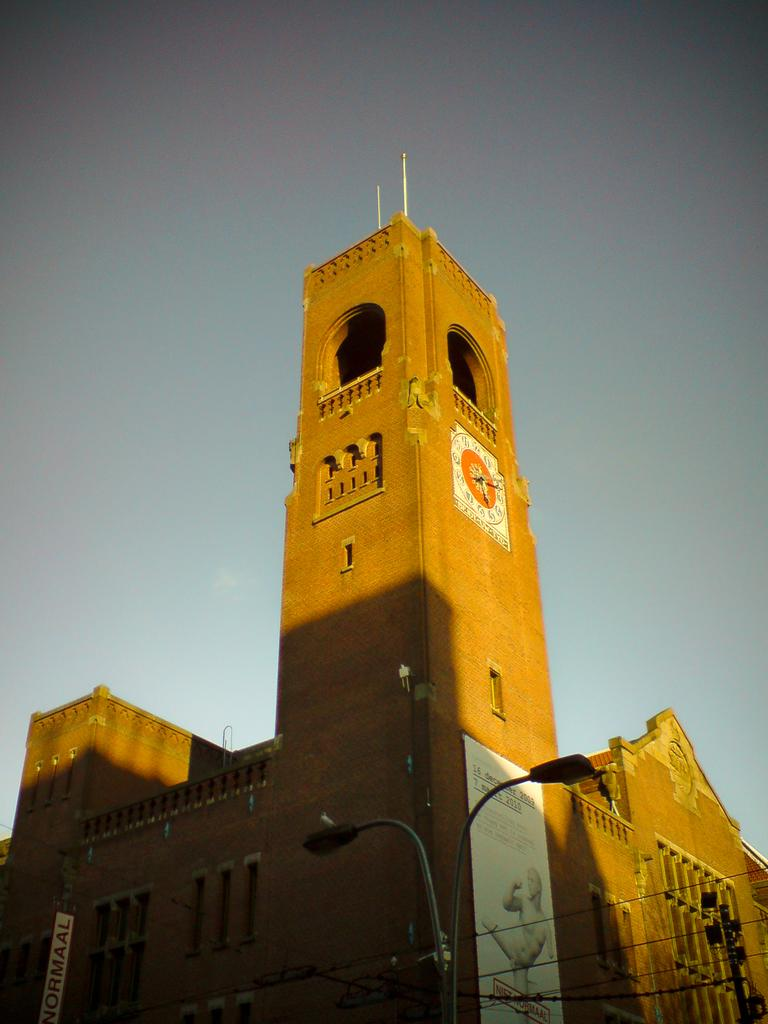What type of structure is visible in the image? There is a building in the image. What else can be seen in the image besides the building? Electric wires, a poster, a light, an electric pole, a clock, and the sky are visible in the image. Can you describe the poster in the image? Unfortunately, the facts provided do not give any details about the poster. What is the source of light in the image? A light is visible in the image, but the facts do not specify its source. What time might it be based on the presence of the clock in the image? Unfortunately, the facts provided do not give any details about the time displayed on the clock. What type of soap is being used to clean the waste in the image? There is no waste or soap present in the image. 